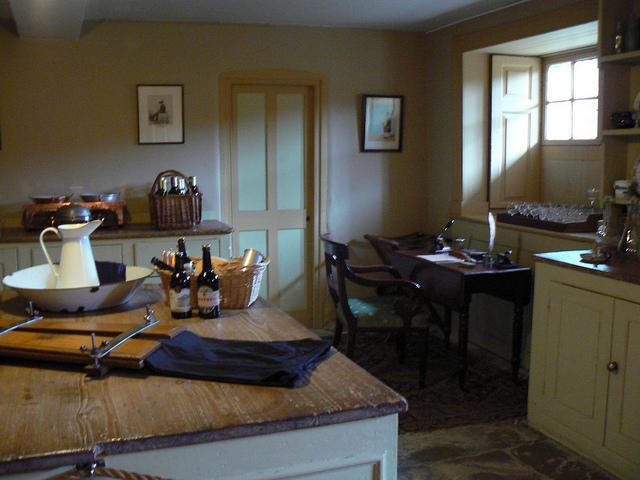How many pictures are hanging on the wall? two 